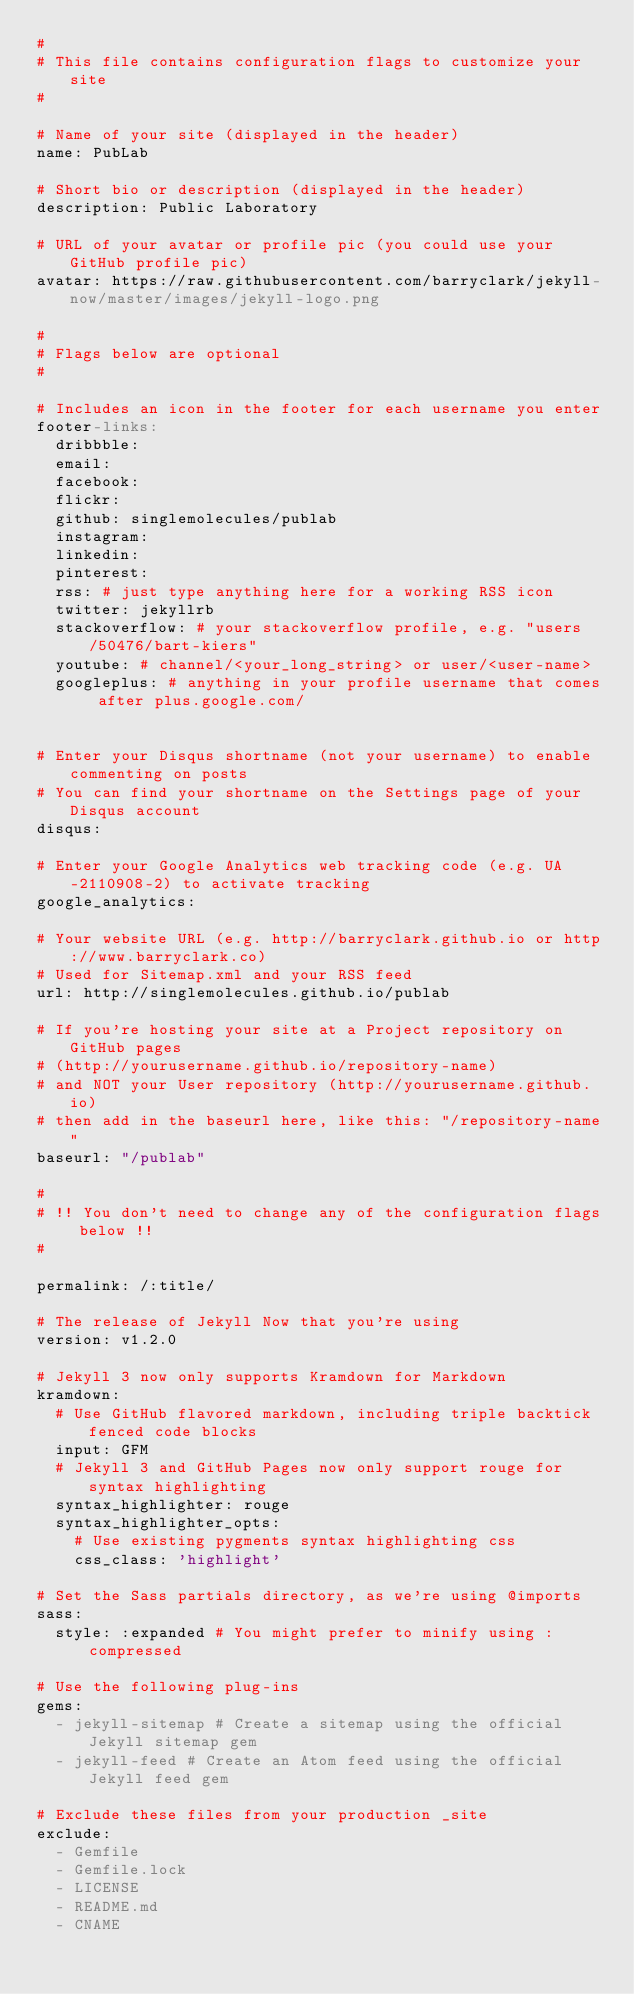Convert code to text. <code><loc_0><loc_0><loc_500><loc_500><_YAML_>#
# This file contains configuration flags to customize your site
#

# Name of your site (displayed in the header)
name: PubLab

# Short bio or description (displayed in the header)
description: Public Laboratory

# URL of your avatar or profile pic (you could use your GitHub profile pic)
avatar: https://raw.githubusercontent.com/barryclark/jekyll-now/master/images/jekyll-logo.png

#
# Flags below are optional
#

# Includes an icon in the footer for each username you enter
footer-links:
  dribbble:
  email:
  facebook:
  flickr:
  github: singlemolecules/publab
  instagram:
  linkedin:
  pinterest:
  rss: # just type anything here for a working RSS icon
  twitter: jekyllrb
  stackoverflow: # your stackoverflow profile, e.g. "users/50476/bart-kiers"
  youtube: # channel/<your_long_string> or user/<user-name>
  googleplus: # anything in your profile username that comes after plus.google.com/


# Enter your Disqus shortname (not your username) to enable commenting on posts
# You can find your shortname on the Settings page of your Disqus account
disqus:

# Enter your Google Analytics web tracking code (e.g. UA-2110908-2) to activate tracking
google_analytics:

# Your website URL (e.g. http://barryclark.github.io or http://www.barryclark.co)
# Used for Sitemap.xml and your RSS feed
url: http://singlemolecules.github.io/publab

# If you're hosting your site at a Project repository on GitHub pages
# (http://yourusername.github.io/repository-name)
# and NOT your User repository (http://yourusername.github.io)
# then add in the baseurl here, like this: "/repository-name"
baseurl: "/publab"

#
# !! You don't need to change any of the configuration flags below !!
#

permalink: /:title/

# The release of Jekyll Now that you're using
version: v1.2.0

# Jekyll 3 now only supports Kramdown for Markdown
kramdown:
  # Use GitHub flavored markdown, including triple backtick fenced code blocks
  input: GFM
  # Jekyll 3 and GitHub Pages now only support rouge for syntax highlighting
  syntax_highlighter: rouge
  syntax_highlighter_opts:
    # Use existing pygments syntax highlighting css
    css_class: 'highlight'

# Set the Sass partials directory, as we're using @imports
sass:
  style: :expanded # You might prefer to minify using :compressed

# Use the following plug-ins
gems:
  - jekyll-sitemap # Create a sitemap using the official Jekyll sitemap gem
  - jekyll-feed # Create an Atom feed using the official Jekyll feed gem

# Exclude these files from your production _site
exclude:
  - Gemfile
  - Gemfile.lock
  - LICENSE
  - README.md
  - CNAME
</code> 